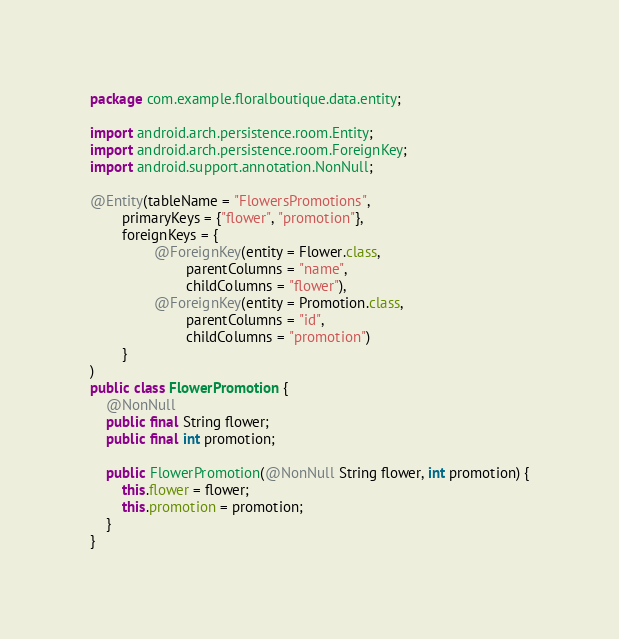Convert code to text. <code><loc_0><loc_0><loc_500><loc_500><_Java_>package com.example.floralboutique.data.entity;

import android.arch.persistence.room.Entity;
import android.arch.persistence.room.ForeignKey;
import android.support.annotation.NonNull;

@Entity(tableName = "FlowersPromotions",
        primaryKeys = {"flower", "promotion"},
        foreignKeys = {
                @ForeignKey(entity = Flower.class,
                        parentColumns = "name",
                        childColumns = "flower"),
                @ForeignKey(entity = Promotion.class,
                        parentColumns = "id",
                        childColumns = "promotion")
        }
)
public class FlowerPromotion {
    @NonNull
    public final String flower;
    public final int promotion;

    public FlowerPromotion(@NonNull String flower, int promotion) {
        this.flower = flower;
        this.promotion = promotion;
    }
}
</code> 